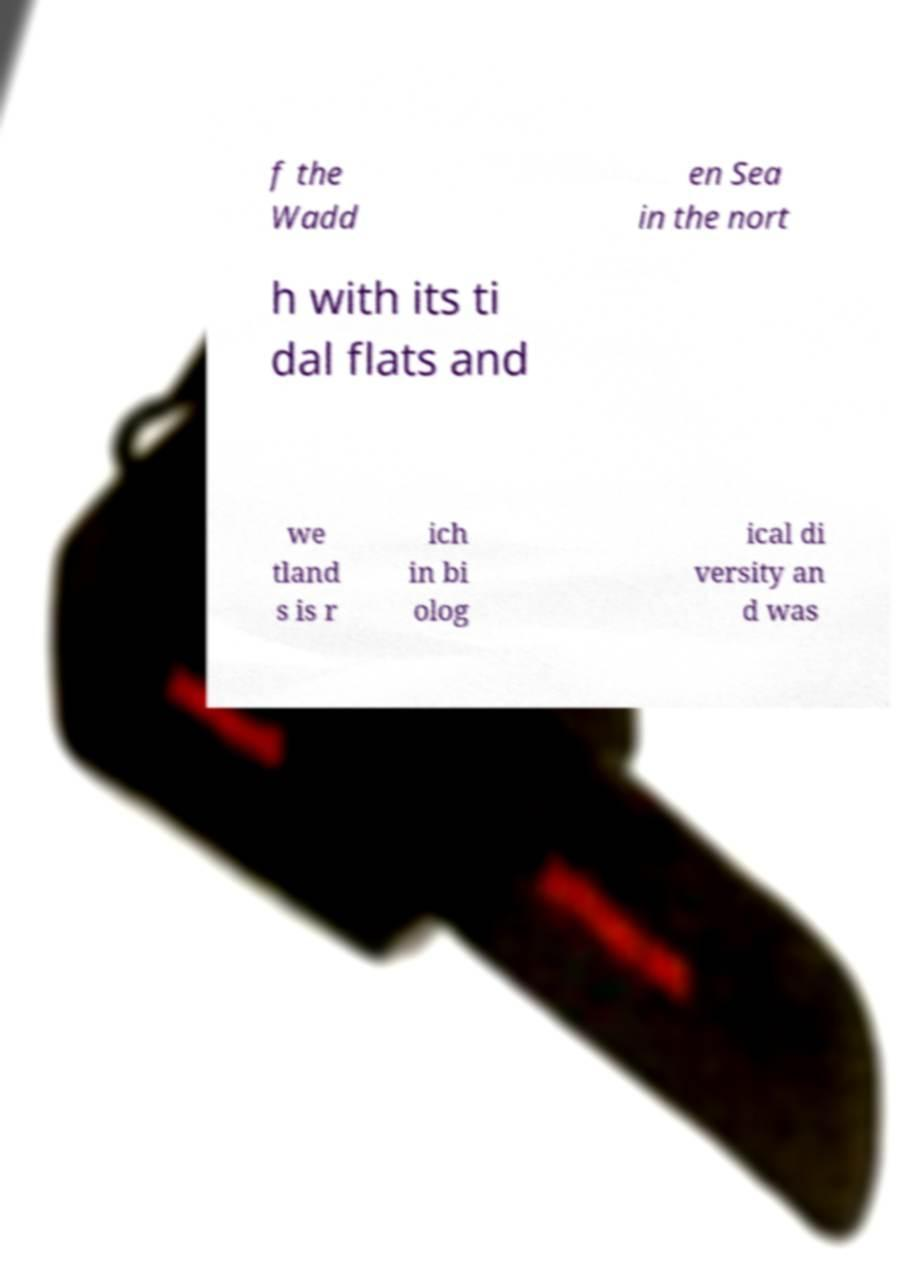Could you extract and type out the text from this image? f the Wadd en Sea in the nort h with its ti dal flats and we tland s is r ich in bi olog ical di versity an d was 